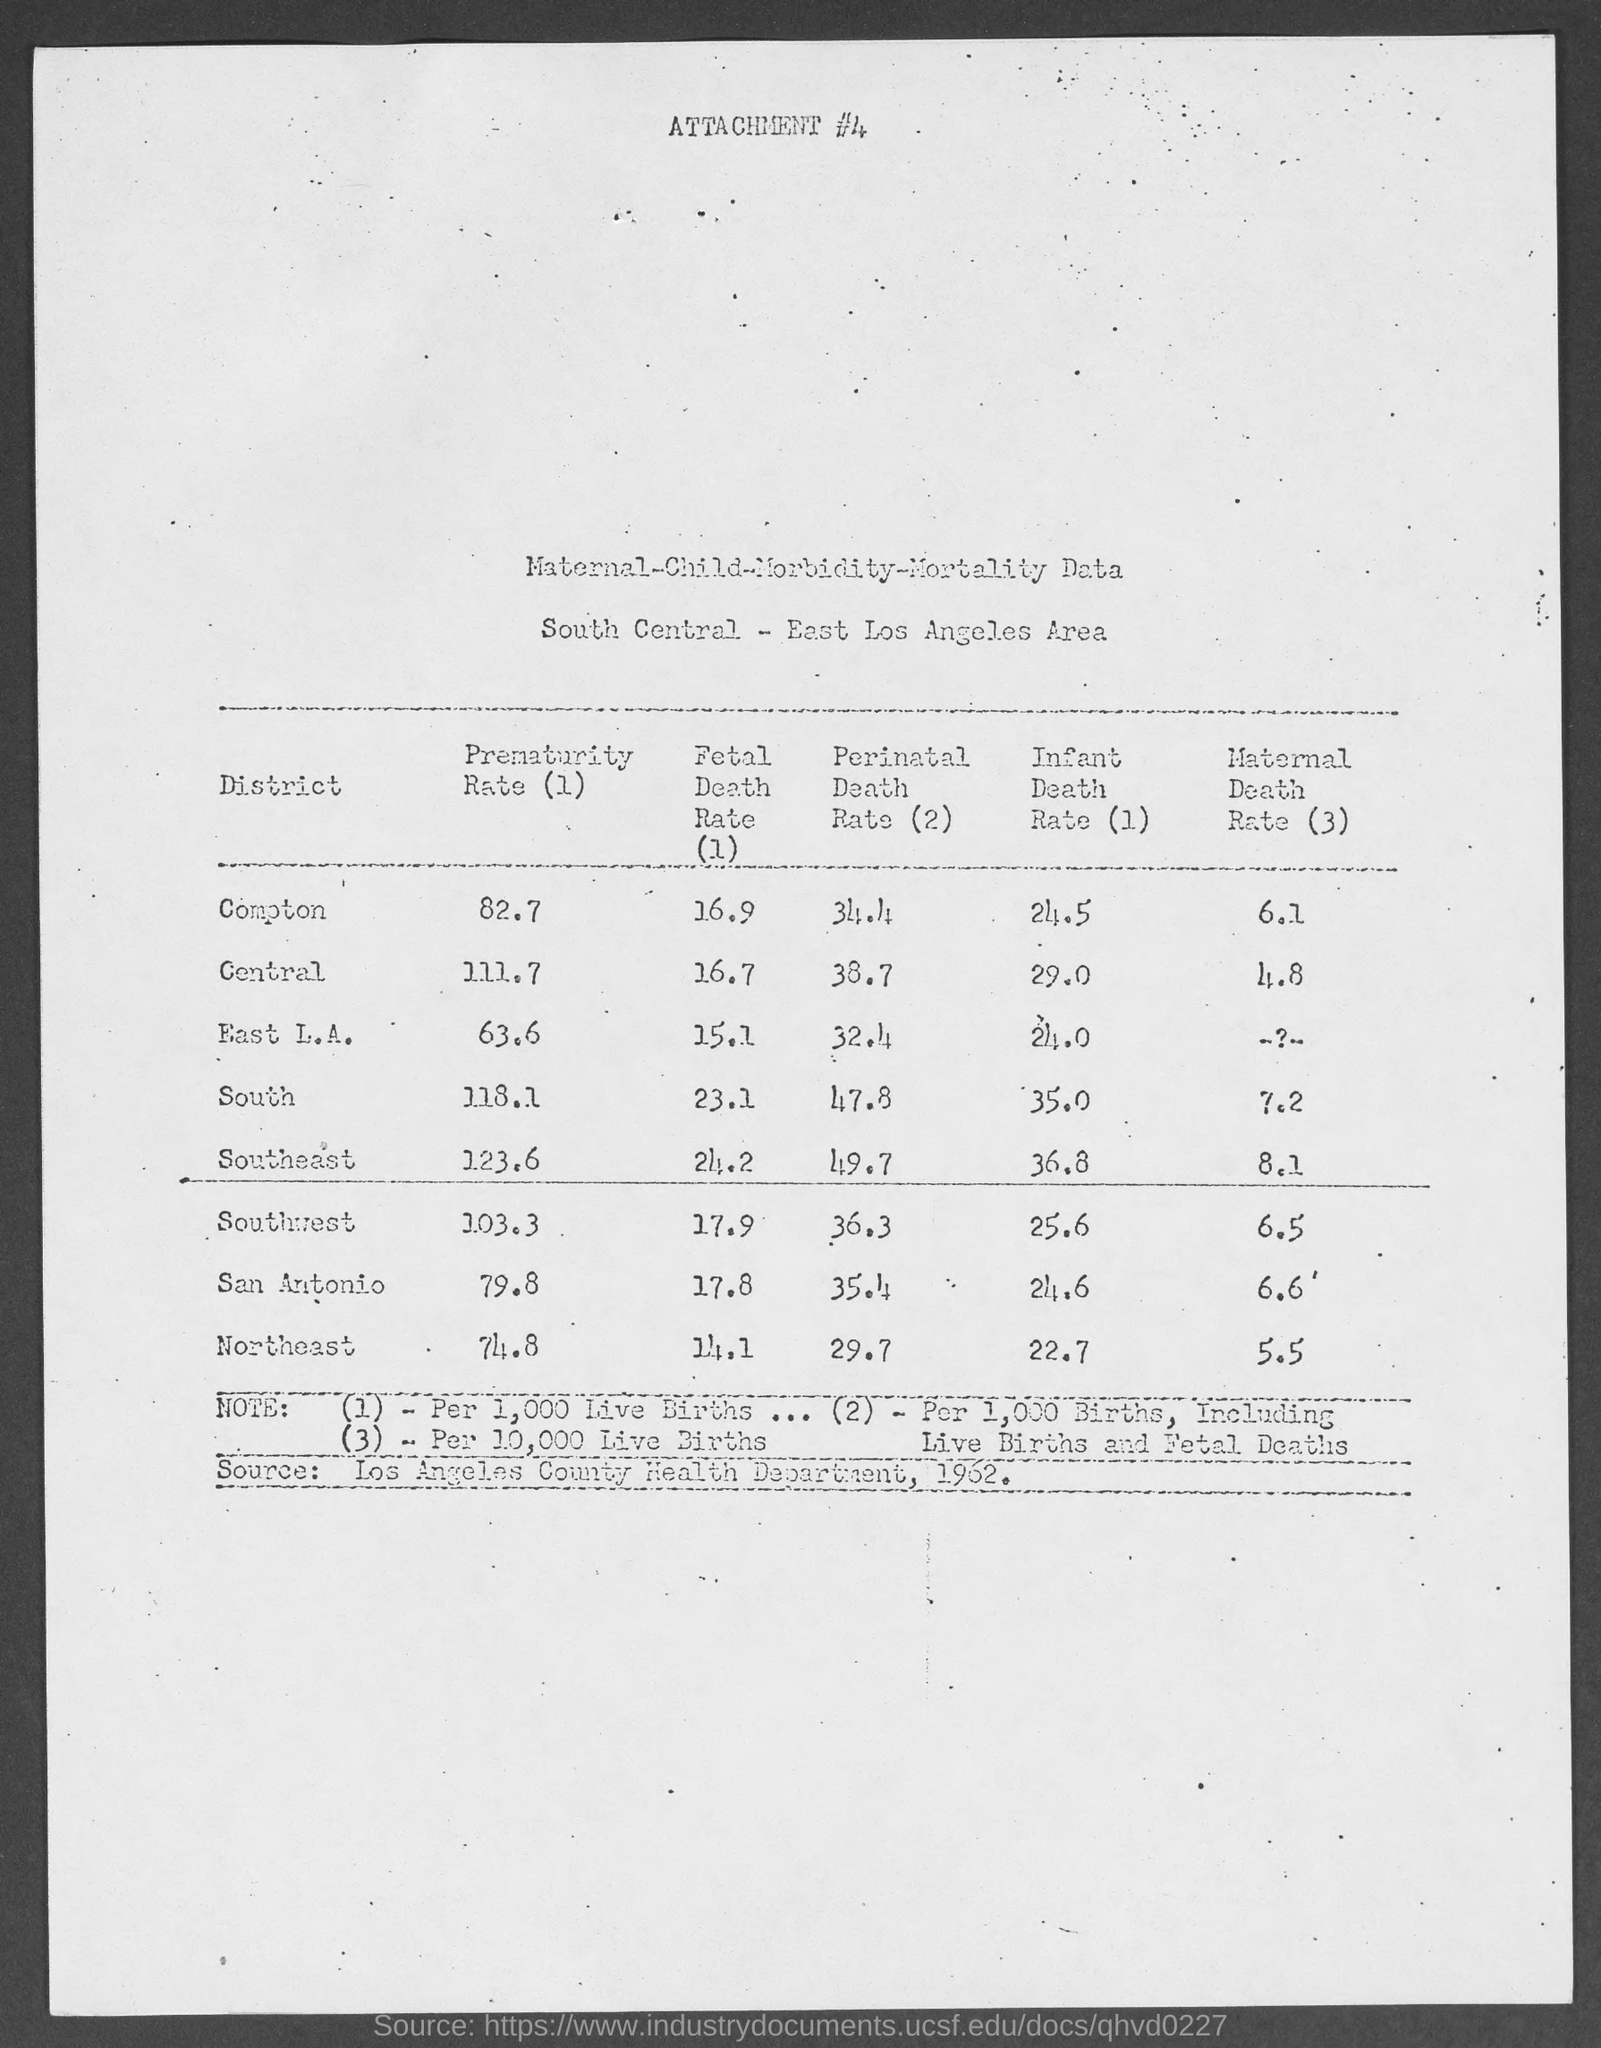What  is the prematurity rate in compton as mentioned in the given page ?
Your response must be concise. 82.7. What is the fetal death rate in compton as mentioned in the given table ?
Provide a succinct answer. 16.9. What is the perinatal death rate in compton as mentioned in the given table ?
Offer a very short reply. 34.4. What is the infant death rate in compton as mentioned in the given table ?
Ensure brevity in your answer.  24.5. What is the maternal death rate in compton as mentioned in the given table ?
Provide a succinct answer. 6.1. What is the prematurity rate in central as mentioned in the given table ?
Your answer should be compact. 111.7. What is the fetal death rate in central as mentioned in the given table ?
Provide a succinct answer. 16.7. What is the perinatal death rate in central as mentioned in the given table ?
Your answer should be very brief. 38.7. What is the infant death rate in central as mentioned in the given table ?
Provide a succinct answer. 29.0. What is the maternal death rate in central as mentioned in the given table ?
Offer a very short reply. 4.8. 